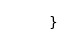Convert code to text. <code><loc_0><loc_0><loc_500><loc_500><_Kotlin_>}
</code> 